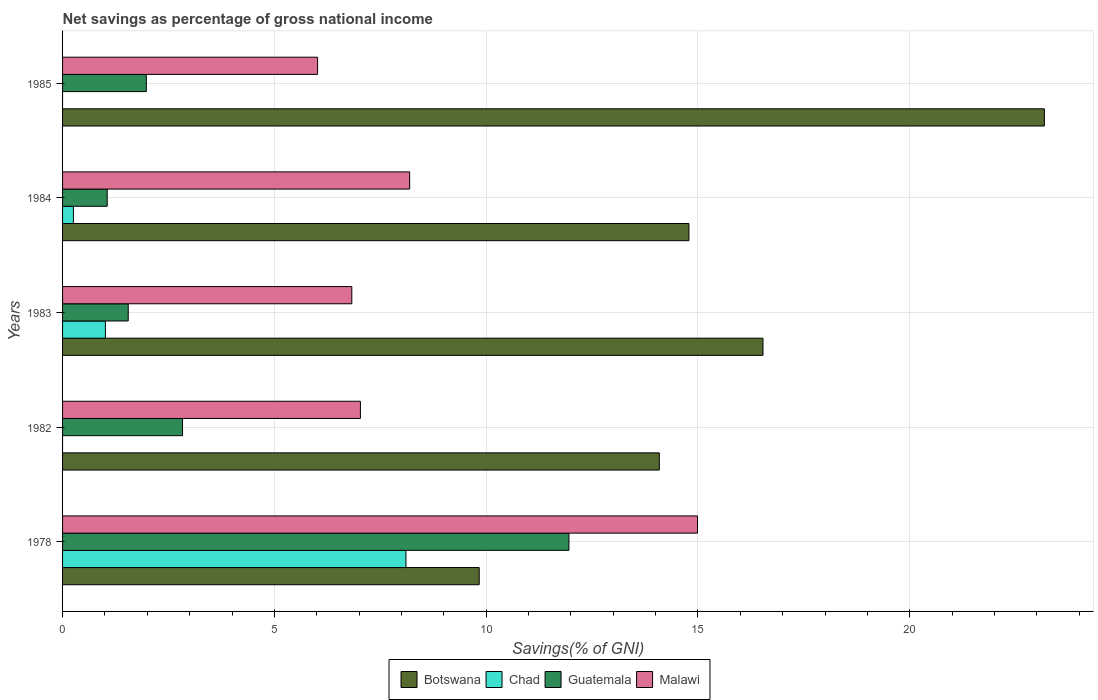How many groups of bars are there?
Your answer should be very brief. 5. Are the number of bars per tick equal to the number of legend labels?
Your response must be concise. No. Are the number of bars on each tick of the Y-axis equal?
Your answer should be very brief. No. How many bars are there on the 4th tick from the top?
Your answer should be very brief. 3. How many bars are there on the 3rd tick from the bottom?
Make the answer very short. 4. What is the label of the 1st group of bars from the top?
Keep it short and to the point. 1985. In how many cases, is the number of bars for a given year not equal to the number of legend labels?
Provide a short and direct response. 2. What is the total savings in Malawi in 1982?
Give a very brief answer. 7.03. Across all years, what is the maximum total savings in Botswana?
Give a very brief answer. 23.18. Across all years, what is the minimum total savings in Chad?
Ensure brevity in your answer.  0. What is the total total savings in Botswana in the graph?
Ensure brevity in your answer.  78.42. What is the difference between the total savings in Botswana in 1984 and that in 1985?
Your answer should be very brief. -8.39. What is the difference between the total savings in Guatemala in 1983 and the total savings in Chad in 1984?
Give a very brief answer. 1.29. What is the average total savings in Malawi per year?
Your response must be concise. 8.61. In the year 1978, what is the difference between the total savings in Botswana and total savings in Guatemala?
Your answer should be very brief. -2.12. What is the ratio of the total savings in Botswana in 1983 to that in 1985?
Your answer should be compact. 0.71. What is the difference between the highest and the second highest total savings in Malawi?
Offer a terse response. 6.8. What is the difference between the highest and the lowest total savings in Guatemala?
Ensure brevity in your answer.  10.9. Is the sum of the total savings in Botswana in 1983 and 1985 greater than the maximum total savings in Chad across all years?
Your answer should be compact. Yes. Are all the bars in the graph horizontal?
Offer a terse response. Yes. Are the values on the major ticks of X-axis written in scientific E-notation?
Offer a terse response. No. Where does the legend appear in the graph?
Offer a terse response. Bottom center. What is the title of the graph?
Give a very brief answer. Net savings as percentage of gross national income. What is the label or title of the X-axis?
Keep it short and to the point. Savings(% of GNI). What is the label or title of the Y-axis?
Ensure brevity in your answer.  Years. What is the Savings(% of GNI) in Botswana in 1978?
Your answer should be very brief. 9.84. What is the Savings(% of GNI) in Chad in 1978?
Your answer should be very brief. 8.11. What is the Savings(% of GNI) of Guatemala in 1978?
Offer a very short reply. 11.95. What is the Savings(% of GNI) of Malawi in 1978?
Your response must be concise. 14.99. What is the Savings(% of GNI) in Botswana in 1982?
Offer a very short reply. 14.09. What is the Savings(% of GNI) of Chad in 1982?
Your response must be concise. 0. What is the Savings(% of GNI) in Guatemala in 1982?
Provide a succinct answer. 2.83. What is the Savings(% of GNI) of Malawi in 1982?
Ensure brevity in your answer.  7.03. What is the Savings(% of GNI) in Botswana in 1983?
Provide a short and direct response. 16.54. What is the Savings(% of GNI) of Chad in 1983?
Make the answer very short. 1.01. What is the Savings(% of GNI) of Guatemala in 1983?
Offer a terse response. 1.55. What is the Savings(% of GNI) of Malawi in 1983?
Provide a succinct answer. 6.83. What is the Savings(% of GNI) of Botswana in 1984?
Keep it short and to the point. 14.79. What is the Savings(% of GNI) in Chad in 1984?
Ensure brevity in your answer.  0.26. What is the Savings(% of GNI) in Guatemala in 1984?
Your answer should be compact. 1.05. What is the Savings(% of GNI) in Malawi in 1984?
Your answer should be compact. 8.19. What is the Savings(% of GNI) in Botswana in 1985?
Keep it short and to the point. 23.18. What is the Savings(% of GNI) in Chad in 1985?
Keep it short and to the point. 0. What is the Savings(% of GNI) of Guatemala in 1985?
Provide a succinct answer. 1.98. What is the Savings(% of GNI) in Malawi in 1985?
Your answer should be very brief. 6.02. Across all years, what is the maximum Savings(% of GNI) in Botswana?
Give a very brief answer. 23.18. Across all years, what is the maximum Savings(% of GNI) in Chad?
Your answer should be very brief. 8.11. Across all years, what is the maximum Savings(% of GNI) in Guatemala?
Offer a very short reply. 11.95. Across all years, what is the maximum Savings(% of GNI) of Malawi?
Your answer should be compact. 14.99. Across all years, what is the minimum Savings(% of GNI) in Botswana?
Provide a succinct answer. 9.84. Across all years, what is the minimum Savings(% of GNI) in Guatemala?
Ensure brevity in your answer.  1.05. Across all years, what is the minimum Savings(% of GNI) of Malawi?
Offer a terse response. 6.02. What is the total Savings(% of GNI) in Botswana in the graph?
Provide a short and direct response. 78.42. What is the total Savings(% of GNI) of Chad in the graph?
Provide a succinct answer. 9.37. What is the total Savings(% of GNI) of Guatemala in the graph?
Give a very brief answer. 19.37. What is the total Savings(% of GNI) of Malawi in the graph?
Your answer should be very brief. 43.06. What is the difference between the Savings(% of GNI) of Botswana in 1978 and that in 1982?
Ensure brevity in your answer.  -4.25. What is the difference between the Savings(% of GNI) of Guatemala in 1978 and that in 1982?
Make the answer very short. 9.12. What is the difference between the Savings(% of GNI) in Malawi in 1978 and that in 1982?
Provide a succinct answer. 7.96. What is the difference between the Savings(% of GNI) in Botswana in 1978 and that in 1983?
Give a very brief answer. -6.7. What is the difference between the Savings(% of GNI) in Chad in 1978 and that in 1983?
Give a very brief answer. 7.1. What is the difference between the Savings(% of GNI) in Guatemala in 1978 and that in 1983?
Offer a terse response. 10.4. What is the difference between the Savings(% of GNI) of Malawi in 1978 and that in 1983?
Offer a very short reply. 8.16. What is the difference between the Savings(% of GNI) in Botswana in 1978 and that in 1984?
Make the answer very short. -4.95. What is the difference between the Savings(% of GNI) in Chad in 1978 and that in 1984?
Make the answer very short. 7.85. What is the difference between the Savings(% of GNI) in Guatemala in 1978 and that in 1984?
Provide a succinct answer. 10.9. What is the difference between the Savings(% of GNI) of Malawi in 1978 and that in 1984?
Keep it short and to the point. 6.8. What is the difference between the Savings(% of GNI) of Botswana in 1978 and that in 1985?
Offer a terse response. -13.34. What is the difference between the Savings(% of GNI) of Guatemala in 1978 and that in 1985?
Give a very brief answer. 9.98. What is the difference between the Savings(% of GNI) in Malawi in 1978 and that in 1985?
Give a very brief answer. 8.97. What is the difference between the Savings(% of GNI) in Botswana in 1982 and that in 1983?
Make the answer very short. -2.45. What is the difference between the Savings(% of GNI) of Guatemala in 1982 and that in 1983?
Offer a very short reply. 1.28. What is the difference between the Savings(% of GNI) of Malawi in 1982 and that in 1983?
Provide a succinct answer. 0.2. What is the difference between the Savings(% of GNI) of Botswana in 1982 and that in 1984?
Give a very brief answer. -0.7. What is the difference between the Savings(% of GNI) of Guatemala in 1982 and that in 1984?
Provide a succinct answer. 1.78. What is the difference between the Savings(% of GNI) in Malawi in 1982 and that in 1984?
Keep it short and to the point. -1.16. What is the difference between the Savings(% of GNI) in Botswana in 1982 and that in 1985?
Keep it short and to the point. -9.09. What is the difference between the Savings(% of GNI) in Guatemala in 1982 and that in 1985?
Offer a very short reply. 0.85. What is the difference between the Savings(% of GNI) of Malawi in 1982 and that in 1985?
Provide a short and direct response. 1.01. What is the difference between the Savings(% of GNI) of Botswana in 1983 and that in 1984?
Provide a short and direct response. 1.75. What is the difference between the Savings(% of GNI) of Chad in 1983 and that in 1984?
Your answer should be compact. 0.76. What is the difference between the Savings(% of GNI) of Guatemala in 1983 and that in 1984?
Your answer should be very brief. 0.5. What is the difference between the Savings(% of GNI) in Malawi in 1983 and that in 1984?
Provide a short and direct response. -1.36. What is the difference between the Savings(% of GNI) of Botswana in 1983 and that in 1985?
Provide a short and direct response. -6.64. What is the difference between the Savings(% of GNI) of Guatemala in 1983 and that in 1985?
Ensure brevity in your answer.  -0.43. What is the difference between the Savings(% of GNI) in Malawi in 1983 and that in 1985?
Offer a very short reply. 0.81. What is the difference between the Savings(% of GNI) in Botswana in 1984 and that in 1985?
Your answer should be compact. -8.39. What is the difference between the Savings(% of GNI) of Guatemala in 1984 and that in 1985?
Keep it short and to the point. -0.92. What is the difference between the Savings(% of GNI) in Malawi in 1984 and that in 1985?
Give a very brief answer. 2.17. What is the difference between the Savings(% of GNI) in Botswana in 1978 and the Savings(% of GNI) in Guatemala in 1982?
Provide a short and direct response. 7. What is the difference between the Savings(% of GNI) of Botswana in 1978 and the Savings(% of GNI) of Malawi in 1982?
Offer a terse response. 2.8. What is the difference between the Savings(% of GNI) in Chad in 1978 and the Savings(% of GNI) in Guatemala in 1982?
Provide a short and direct response. 5.27. What is the difference between the Savings(% of GNI) in Chad in 1978 and the Savings(% of GNI) in Malawi in 1982?
Your response must be concise. 1.08. What is the difference between the Savings(% of GNI) in Guatemala in 1978 and the Savings(% of GNI) in Malawi in 1982?
Offer a very short reply. 4.92. What is the difference between the Savings(% of GNI) in Botswana in 1978 and the Savings(% of GNI) in Chad in 1983?
Your answer should be very brief. 8.82. What is the difference between the Savings(% of GNI) in Botswana in 1978 and the Savings(% of GNI) in Guatemala in 1983?
Your response must be concise. 8.29. What is the difference between the Savings(% of GNI) in Botswana in 1978 and the Savings(% of GNI) in Malawi in 1983?
Keep it short and to the point. 3.01. What is the difference between the Savings(% of GNI) of Chad in 1978 and the Savings(% of GNI) of Guatemala in 1983?
Offer a terse response. 6.56. What is the difference between the Savings(% of GNI) of Chad in 1978 and the Savings(% of GNI) of Malawi in 1983?
Keep it short and to the point. 1.28. What is the difference between the Savings(% of GNI) of Guatemala in 1978 and the Savings(% of GNI) of Malawi in 1983?
Your response must be concise. 5.13. What is the difference between the Savings(% of GNI) in Botswana in 1978 and the Savings(% of GNI) in Chad in 1984?
Your answer should be compact. 9.58. What is the difference between the Savings(% of GNI) in Botswana in 1978 and the Savings(% of GNI) in Guatemala in 1984?
Your answer should be compact. 8.78. What is the difference between the Savings(% of GNI) of Botswana in 1978 and the Savings(% of GNI) of Malawi in 1984?
Your answer should be very brief. 1.64. What is the difference between the Savings(% of GNI) in Chad in 1978 and the Savings(% of GNI) in Guatemala in 1984?
Offer a very short reply. 7.05. What is the difference between the Savings(% of GNI) of Chad in 1978 and the Savings(% of GNI) of Malawi in 1984?
Provide a short and direct response. -0.09. What is the difference between the Savings(% of GNI) of Guatemala in 1978 and the Savings(% of GNI) of Malawi in 1984?
Ensure brevity in your answer.  3.76. What is the difference between the Savings(% of GNI) in Botswana in 1978 and the Savings(% of GNI) in Guatemala in 1985?
Give a very brief answer. 7.86. What is the difference between the Savings(% of GNI) in Botswana in 1978 and the Savings(% of GNI) in Malawi in 1985?
Your answer should be compact. 3.81. What is the difference between the Savings(% of GNI) in Chad in 1978 and the Savings(% of GNI) in Guatemala in 1985?
Give a very brief answer. 6.13. What is the difference between the Savings(% of GNI) of Chad in 1978 and the Savings(% of GNI) of Malawi in 1985?
Offer a very short reply. 2.09. What is the difference between the Savings(% of GNI) of Guatemala in 1978 and the Savings(% of GNI) of Malawi in 1985?
Offer a terse response. 5.93. What is the difference between the Savings(% of GNI) of Botswana in 1982 and the Savings(% of GNI) of Chad in 1983?
Provide a succinct answer. 13.08. What is the difference between the Savings(% of GNI) of Botswana in 1982 and the Savings(% of GNI) of Guatemala in 1983?
Your response must be concise. 12.54. What is the difference between the Savings(% of GNI) of Botswana in 1982 and the Savings(% of GNI) of Malawi in 1983?
Give a very brief answer. 7.26. What is the difference between the Savings(% of GNI) in Guatemala in 1982 and the Savings(% of GNI) in Malawi in 1983?
Keep it short and to the point. -4. What is the difference between the Savings(% of GNI) of Botswana in 1982 and the Savings(% of GNI) of Chad in 1984?
Ensure brevity in your answer.  13.83. What is the difference between the Savings(% of GNI) of Botswana in 1982 and the Savings(% of GNI) of Guatemala in 1984?
Provide a short and direct response. 13.03. What is the difference between the Savings(% of GNI) in Botswana in 1982 and the Savings(% of GNI) in Malawi in 1984?
Ensure brevity in your answer.  5.89. What is the difference between the Savings(% of GNI) in Guatemala in 1982 and the Savings(% of GNI) in Malawi in 1984?
Provide a succinct answer. -5.36. What is the difference between the Savings(% of GNI) of Botswana in 1982 and the Savings(% of GNI) of Guatemala in 1985?
Provide a short and direct response. 12.11. What is the difference between the Savings(% of GNI) in Botswana in 1982 and the Savings(% of GNI) in Malawi in 1985?
Give a very brief answer. 8.07. What is the difference between the Savings(% of GNI) in Guatemala in 1982 and the Savings(% of GNI) in Malawi in 1985?
Provide a short and direct response. -3.19. What is the difference between the Savings(% of GNI) of Botswana in 1983 and the Savings(% of GNI) of Chad in 1984?
Provide a succinct answer. 16.28. What is the difference between the Savings(% of GNI) in Botswana in 1983 and the Savings(% of GNI) in Guatemala in 1984?
Your answer should be very brief. 15.48. What is the difference between the Savings(% of GNI) in Botswana in 1983 and the Savings(% of GNI) in Malawi in 1984?
Make the answer very short. 8.34. What is the difference between the Savings(% of GNI) of Chad in 1983 and the Savings(% of GNI) of Guatemala in 1984?
Give a very brief answer. -0.04. What is the difference between the Savings(% of GNI) of Chad in 1983 and the Savings(% of GNI) of Malawi in 1984?
Make the answer very short. -7.18. What is the difference between the Savings(% of GNI) of Guatemala in 1983 and the Savings(% of GNI) of Malawi in 1984?
Your response must be concise. -6.64. What is the difference between the Savings(% of GNI) in Botswana in 1983 and the Savings(% of GNI) in Guatemala in 1985?
Offer a terse response. 14.56. What is the difference between the Savings(% of GNI) of Botswana in 1983 and the Savings(% of GNI) of Malawi in 1985?
Provide a succinct answer. 10.51. What is the difference between the Savings(% of GNI) of Chad in 1983 and the Savings(% of GNI) of Guatemala in 1985?
Keep it short and to the point. -0.97. What is the difference between the Savings(% of GNI) in Chad in 1983 and the Savings(% of GNI) in Malawi in 1985?
Offer a terse response. -5.01. What is the difference between the Savings(% of GNI) in Guatemala in 1983 and the Savings(% of GNI) in Malawi in 1985?
Offer a terse response. -4.47. What is the difference between the Savings(% of GNI) in Botswana in 1984 and the Savings(% of GNI) in Guatemala in 1985?
Your answer should be compact. 12.81. What is the difference between the Savings(% of GNI) in Botswana in 1984 and the Savings(% of GNI) in Malawi in 1985?
Provide a short and direct response. 8.77. What is the difference between the Savings(% of GNI) of Chad in 1984 and the Savings(% of GNI) of Guatemala in 1985?
Give a very brief answer. -1.72. What is the difference between the Savings(% of GNI) of Chad in 1984 and the Savings(% of GNI) of Malawi in 1985?
Offer a very short reply. -5.77. What is the difference between the Savings(% of GNI) in Guatemala in 1984 and the Savings(% of GNI) in Malawi in 1985?
Your answer should be very brief. -4.97. What is the average Savings(% of GNI) in Botswana per year?
Keep it short and to the point. 15.68. What is the average Savings(% of GNI) in Chad per year?
Ensure brevity in your answer.  1.87. What is the average Savings(% of GNI) of Guatemala per year?
Keep it short and to the point. 3.87. What is the average Savings(% of GNI) of Malawi per year?
Provide a short and direct response. 8.61. In the year 1978, what is the difference between the Savings(% of GNI) in Botswana and Savings(% of GNI) in Chad?
Provide a short and direct response. 1.73. In the year 1978, what is the difference between the Savings(% of GNI) in Botswana and Savings(% of GNI) in Guatemala?
Provide a short and direct response. -2.12. In the year 1978, what is the difference between the Savings(% of GNI) of Botswana and Savings(% of GNI) of Malawi?
Give a very brief answer. -5.15. In the year 1978, what is the difference between the Savings(% of GNI) in Chad and Savings(% of GNI) in Guatemala?
Offer a terse response. -3.85. In the year 1978, what is the difference between the Savings(% of GNI) in Chad and Savings(% of GNI) in Malawi?
Offer a very short reply. -6.88. In the year 1978, what is the difference between the Savings(% of GNI) of Guatemala and Savings(% of GNI) of Malawi?
Offer a very short reply. -3.04. In the year 1982, what is the difference between the Savings(% of GNI) of Botswana and Savings(% of GNI) of Guatemala?
Provide a succinct answer. 11.26. In the year 1982, what is the difference between the Savings(% of GNI) in Botswana and Savings(% of GNI) in Malawi?
Give a very brief answer. 7.06. In the year 1982, what is the difference between the Savings(% of GNI) in Guatemala and Savings(% of GNI) in Malawi?
Keep it short and to the point. -4.2. In the year 1983, what is the difference between the Savings(% of GNI) of Botswana and Savings(% of GNI) of Chad?
Ensure brevity in your answer.  15.52. In the year 1983, what is the difference between the Savings(% of GNI) of Botswana and Savings(% of GNI) of Guatemala?
Offer a very short reply. 14.98. In the year 1983, what is the difference between the Savings(% of GNI) of Botswana and Savings(% of GNI) of Malawi?
Your answer should be very brief. 9.71. In the year 1983, what is the difference between the Savings(% of GNI) of Chad and Savings(% of GNI) of Guatemala?
Offer a very short reply. -0.54. In the year 1983, what is the difference between the Savings(% of GNI) in Chad and Savings(% of GNI) in Malawi?
Offer a terse response. -5.82. In the year 1983, what is the difference between the Savings(% of GNI) of Guatemala and Savings(% of GNI) of Malawi?
Give a very brief answer. -5.28. In the year 1984, what is the difference between the Savings(% of GNI) in Botswana and Savings(% of GNI) in Chad?
Provide a succinct answer. 14.53. In the year 1984, what is the difference between the Savings(% of GNI) in Botswana and Savings(% of GNI) in Guatemala?
Keep it short and to the point. 13.73. In the year 1984, what is the difference between the Savings(% of GNI) in Botswana and Savings(% of GNI) in Malawi?
Your response must be concise. 6.59. In the year 1984, what is the difference between the Savings(% of GNI) in Chad and Savings(% of GNI) in Guatemala?
Provide a succinct answer. -0.8. In the year 1984, what is the difference between the Savings(% of GNI) in Chad and Savings(% of GNI) in Malawi?
Keep it short and to the point. -7.94. In the year 1984, what is the difference between the Savings(% of GNI) in Guatemala and Savings(% of GNI) in Malawi?
Ensure brevity in your answer.  -7.14. In the year 1985, what is the difference between the Savings(% of GNI) in Botswana and Savings(% of GNI) in Guatemala?
Ensure brevity in your answer.  21.2. In the year 1985, what is the difference between the Savings(% of GNI) in Botswana and Savings(% of GNI) in Malawi?
Your answer should be compact. 17.16. In the year 1985, what is the difference between the Savings(% of GNI) in Guatemala and Savings(% of GNI) in Malawi?
Keep it short and to the point. -4.04. What is the ratio of the Savings(% of GNI) in Botswana in 1978 to that in 1982?
Keep it short and to the point. 0.7. What is the ratio of the Savings(% of GNI) of Guatemala in 1978 to that in 1982?
Offer a terse response. 4.22. What is the ratio of the Savings(% of GNI) of Malawi in 1978 to that in 1982?
Keep it short and to the point. 2.13. What is the ratio of the Savings(% of GNI) in Botswana in 1978 to that in 1983?
Offer a very short reply. 0.59. What is the ratio of the Savings(% of GNI) in Chad in 1978 to that in 1983?
Provide a short and direct response. 8.02. What is the ratio of the Savings(% of GNI) of Guatemala in 1978 to that in 1983?
Provide a short and direct response. 7.71. What is the ratio of the Savings(% of GNI) in Malawi in 1978 to that in 1983?
Your response must be concise. 2.2. What is the ratio of the Savings(% of GNI) of Botswana in 1978 to that in 1984?
Give a very brief answer. 0.67. What is the ratio of the Savings(% of GNI) in Chad in 1978 to that in 1984?
Offer a terse response. 31.73. What is the ratio of the Savings(% of GNI) in Guatemala in 1978 to that in 1984?
Provide a short and direct response. 11.34. What is the ratio of the Savings(% of GNI) in Malawi in 1978 to that in 1984?
Your response must be concise. 1.83. What is the ratio of the Savings(% of GNI) of Botswana in 1978 to that in 1985?
Offer a terse response. 0.42. What is the ratio of the Savings(% of GNI) of Guatemala in 1978 to that in 1985?
Keep it short and to the point. 6.05. What is the ratio of the Savings(% of GNI) in Malawi in 1978 to that in 1985?
Your answer should be very brief. 2.49. What is the ratio of the Savings(% of GNI) of Botswana in 1982 to that in 1983?
Ensure brevity in your answer.  0.85. What is the ratio of the Savings(% of GNI) in Guatemala in 1982 to that in 1983?
Provide a succinct answer. 1.83. What is the ratio of the Savings(% of GNI) in Malawi in 1982 to that in 1983?
Your answer should be very brief. 1.03. What is the ratio of the Savings(% of GNI) of Botswana in 1982 to that in 1984?
Provide a succinct answer. 0.95. What is the ratio of the Savings(% of GNI) of Guatemala in 1982 to that in 1984?
Provide a succinct answer. 2.69. What is the ratio of the Savings(% of GNI) in Malawi in 1982 to that in 1984?
Your answer should be very brief. 0.86. What is the ratio of the Savings(% of GNI) in Botswana in 1982 to that in 1985?
Give a very brief answer. 0.61. What is the ratio of the Savings(% of GNI) in Guatemala in 1982 to that in 1985?
Make the answer very short. 1.43. What is the ratio of the Savings(% of GNI) of Malawi in 1982 to that in 1985?
Keep it short and to the point. 1.17. What is the ratio of the Savings(% of GNI) in Botswana in 1983 to that in 1984?
Provide a succinct answer. 1.12. What is the ratio of the Savings(% of GNI) of Chad in 1983 to that in 1984?
Offer a very short reply. 3.96. What is the ratio of the Savings(% of GNI) of Guatemala in 1983 to that in 1984?
Provide a short and direct response. 1.47. What is the ratio of the Savings(% of GNI) in Malawi in 1983 to that in 1984?
Your answer should be very brief. 0.83. What is the ratio of the Savings(% of GNI) of Botswana in 1983 to that in 1985?
Offer a terse response. 0.71. What is the ratio of the Savings(% of GNI) of Guatemala in 1983 to that in 1985?
Make the answer very short. 0.78. What is the ratio of the Savings(% of GNI) of Malawi in 1983 to that in 1985?
Your response must be concise. 1.13. What is the ratio of the Savings(% of GNI) in Botswana in 1984 to that in 1985?
Ensure brevity in your answer.  0.64. What is the ratio of the Savings(% of GNI) of Guatemala in 1984 to that in 1985?
Provide a succinct answer. 0.53. What is the ratio of the Savings(% of GNI) in Malawi in 1984 to that in 1985?
Make the answer very short. 1.36. What is the difference between the highest and the second highest Savings(% of GNI) in Botswana?
Keep it short and to the point. 6.64. What is the difference between the highest and the second highest Savings(% of GNI) in Chad?
Your answer should be compact. 7.1. What is the difference between the highest and the second highest Savings(% of GNI) in Guatemala?
Offer a terse response. 9.12. What is the difference between the highest and the second highest Savings(% of GNI) of Malawi?
Ensure brevity in your answer.  6.8. What is the difference between the highest and the lowest Savings(% of GNI) in Botswana?
Provide a short and direct response. 13.34. What is the difference between the highest and the lowest Savings(% of GNI) of Chad?
Provide a succinct answer. 8.11. What is the difference between the highest and the lowest Savings(% of GNI) of Guatemala?
Make the answer very short. 10.9. What is the difference between the highest and the lowest Savings(% of GNI) in Malawi?
Offer a terse response. 8.97. 